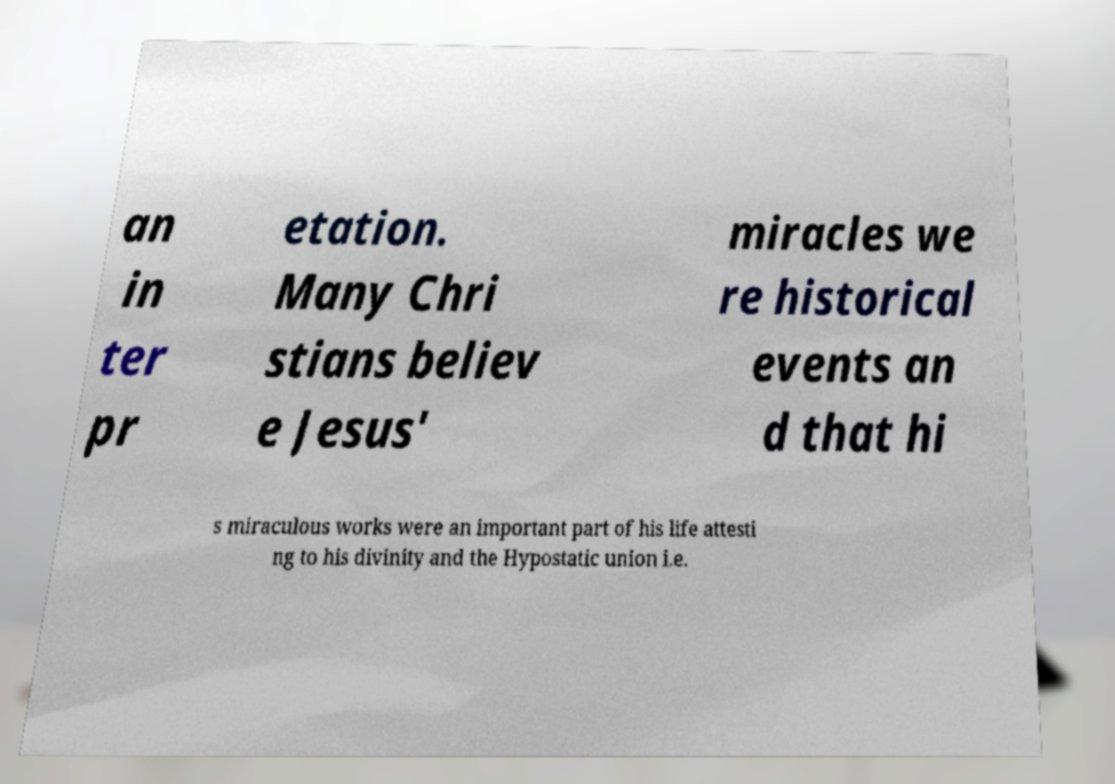There's text embedded in this image that I need extracted. Can you transcribe it verbatim? an in ter pr etation. Many Chri stians believ e Jesus' miracles we re historical events an d that hi s miraculous works were an important part of his life attesti ng to his divinity and the Hypostatic union i.e. 